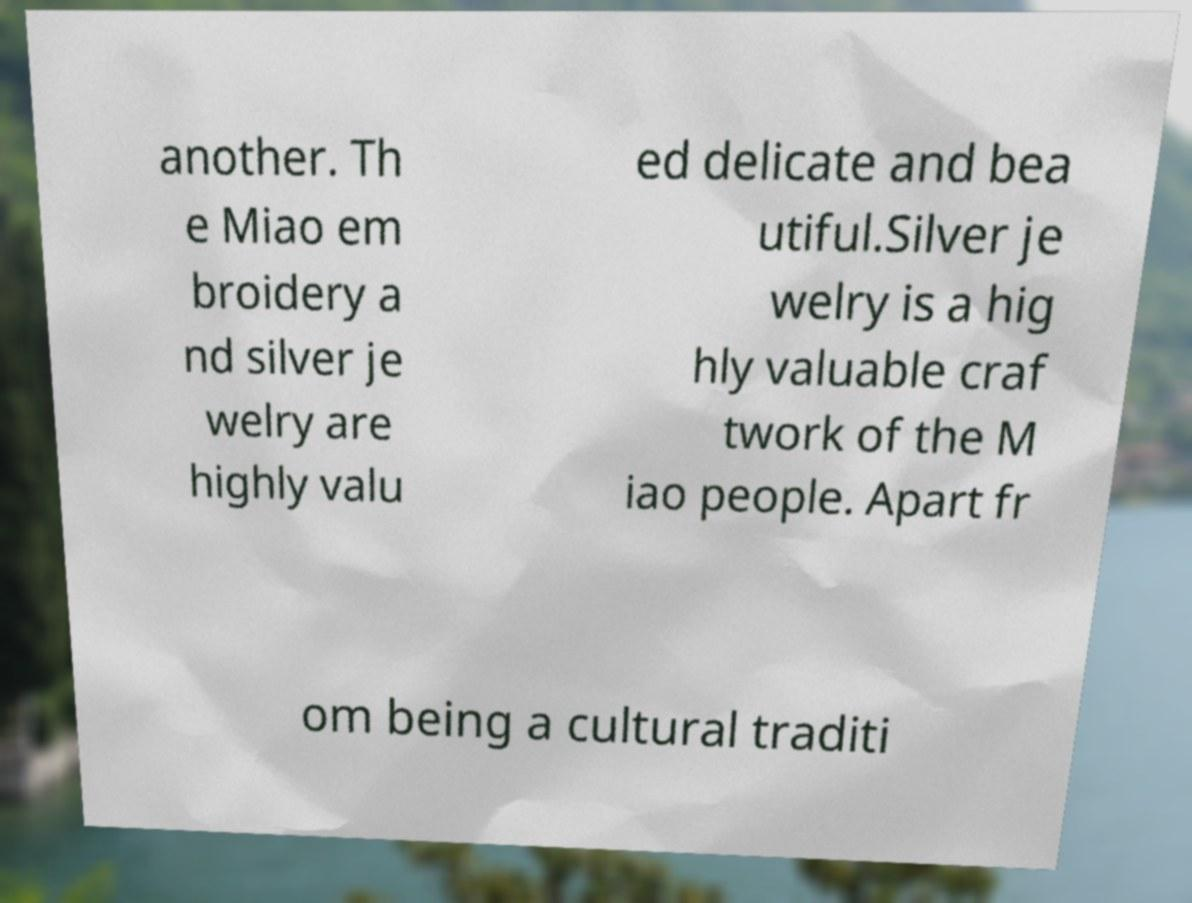Please read and relay the text visible in this image. What does it say? another. Th e Miao em broidery a nd silver je welry are highly valu ed delicate and bea utiful.Silver je welry is a hig hly valuable craf twork of the M iao people. Apart fr om being a cultural traditi 